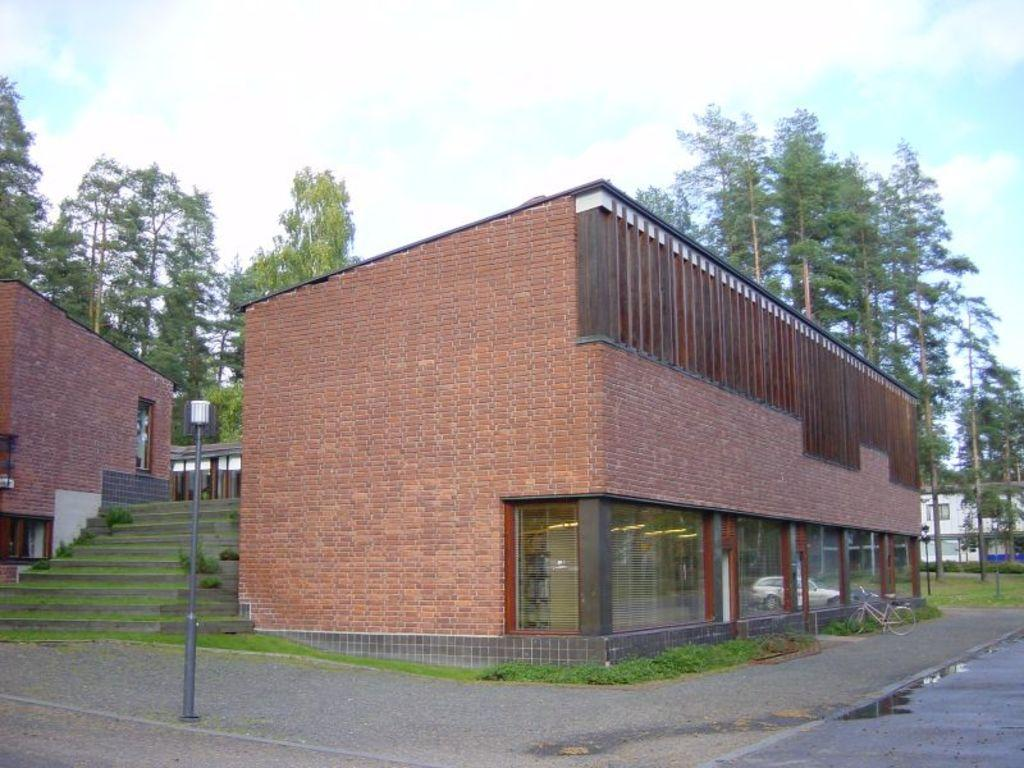What type of pathway is visible in the image? There is a road in the image. What surface is adjacent to the road? There is a pavement in the image. What is one feature that provides light in the image? There is a lamp post in the image. What architectural element allows for vertical movement in the image? There are stairs in the image. What type of vegetation can be seen in the background of the image? There are trees in the background of the image. What type of structures are visible in the background of the image? There are buildings in the background of the image. What mode of transportation is parked on the pavement in the image? There is a cycle parked on the pavement. What type of account is being discussed in the image? There is no discussion of an account in the image. Can you see any wounds on the trees in the background? There are no wounds visible on the trees in the image. 